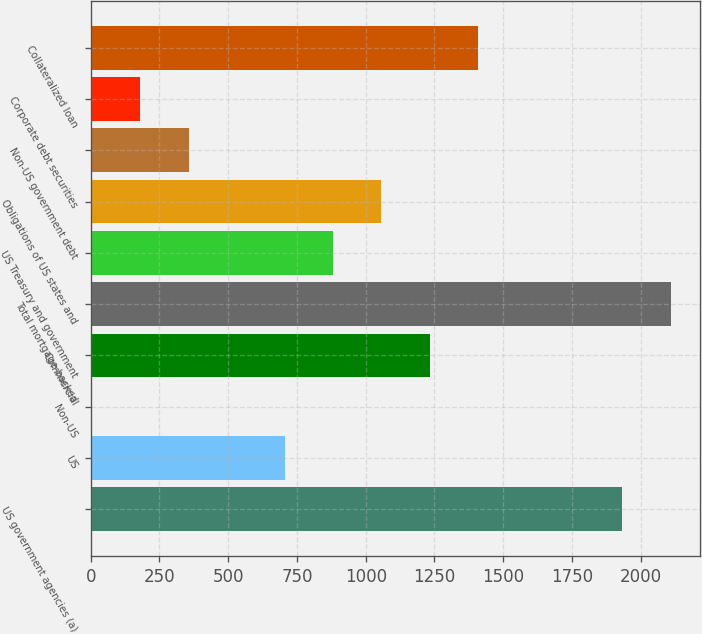<chart> <loc_0><loc_0><loc_500><loc_500><bar_chart><fcel>US government agencies (a)<fcel>US<fcel>Non-US<fcel>Commercial<fcel>Total mortgage-backed<fcel>US Treasury and government<fcel>Obligations of US states and<fcel>Non-US government debt<fcel>Corporate debt securities<fcel>Collateralized loan<nl><fcel>1933.2<fcel>706.8<fcel>6<fcel>1232.4<fcel>2108.4<fcel>882<fcel>1057.2<fcel>356.4<fcel>181.2<fcel>1407.6<nl></chart> 